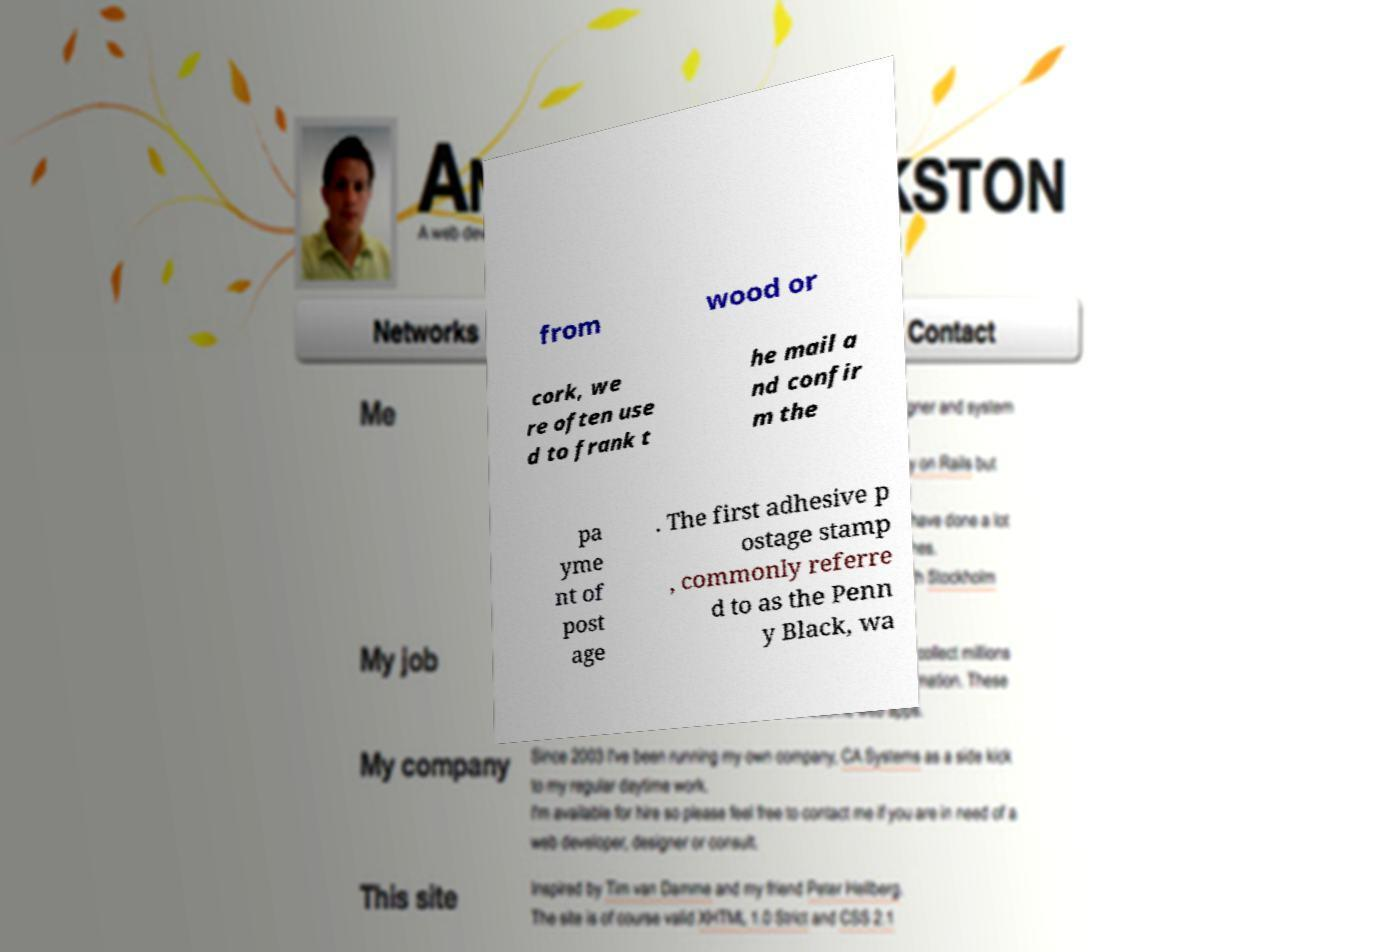Please identify and transcribe the text found in this image. from wood or cork, we re often use d to frank t he mail a nd confir m the pa yme nt of post age . The first adhesive p ostage stamp , commonly referre d to as the Penn y Black, wa 